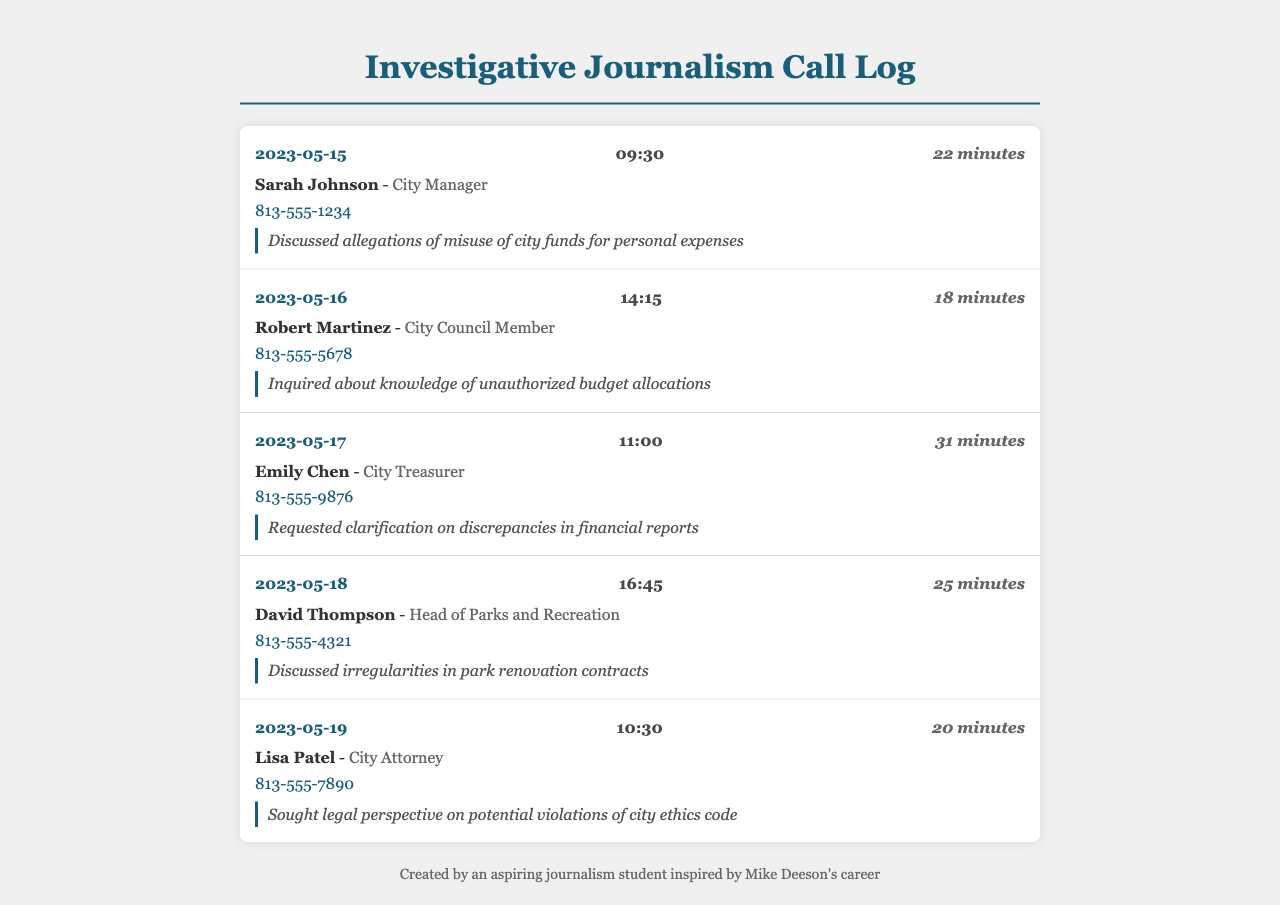What is the date of the first call? The date of the first call is detailed at the top of the call entries in the document.
Answer: 2023-05-15 Who was interviewed on May 17, 2023? The names of the people interviewed are listed under each call entry with the date of the call.
Answer: Emily Chen How long was the call with Sarah Johnson? The duration of each call is specified under the call header for each entry.
Answer: 22 minutes What was discussed during the call with David Thompson? Each call entry contains notes that summarize the topics discussed during the call.
Answer: Irregularities in park renovation contracts What is the contact number for Lisa Patel? Each entry provides a specific contact number associated with the individual being interviewed.
Answer: 813-555-7890 Who is the City Treasurer? The title and name of the individual are mentioned in connection to the call entry for the respective date.
Answer: Emily Chen On what date was the call with Robert Martinez made? The date is noted in the header of the call entry for each interview conducted.
Answer: 2023-05-16 How many minutes long was the call with Emily Chen? The duration of each call is clearly stated in the call entry headers.
Answer: 31 minutes What is the title of Sarah Johnson? The titles of the individuals interviewed are provided alongside their names in the contact information.
Answer: City Manager 